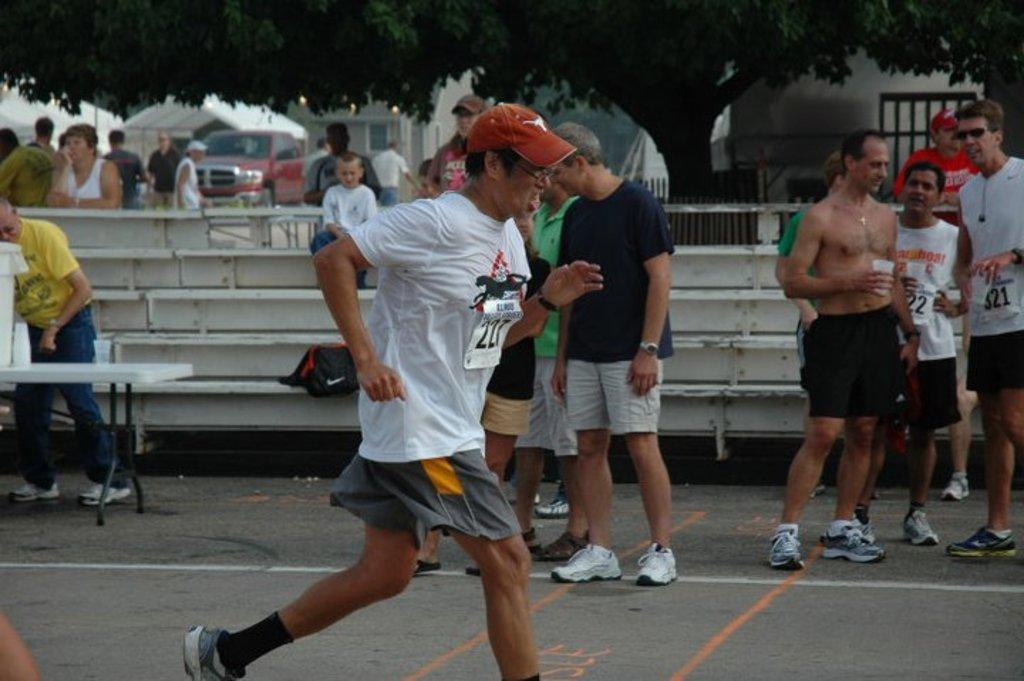What is the man in the middle of the image doing? The man is running in the middle of the image. What are the people in the image doing? There is a group of people standing in the image. What can be seen in the background of the image? There are trees and buildings in the background of the image. What is located on the left side of the image? There is a vehicle on the left side of the image. Can you hear the whistle blowing in the image? There is no whistle present in the image, so it cannot be heard. 